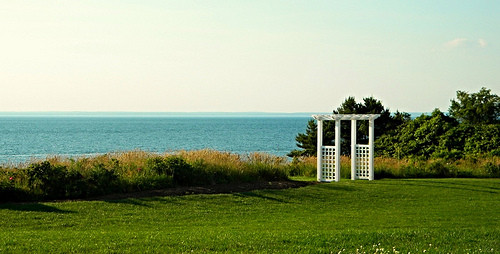<image>
Is the sea in front of the building? Yes. The sea is positioned in front of the building, appearing closer to the camera viewpoint. 